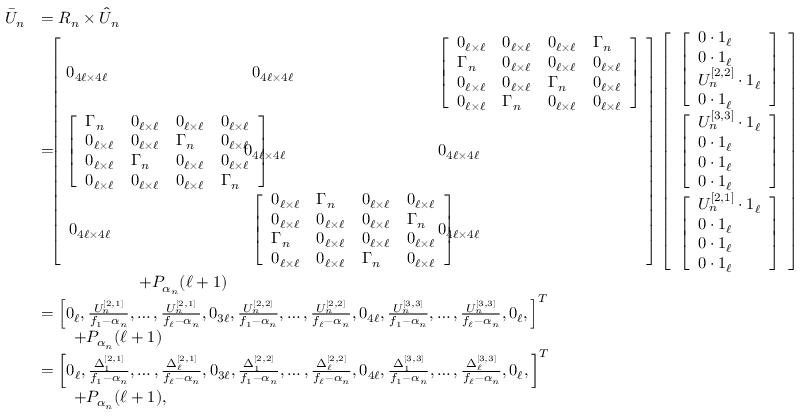<formula> <loc_0><loc_0><loc_500><loc_500>\begin{array} { r l } { \bar { U } _ { n } } & { = R _ { n } \times \hat { U } _ { n } } \\ & { = \, \left [ \begin{array} { l l l } { \, 0 _ { 4 \ell \times 4 \ell } \, } & { \, 0 _ { 4 \ell \times 4 \ell } \, } & { \, \left [ \begin{array} { l l l l } { 0 _ { \ell \times \ell } } & { 0 _ { \ell \times \ell } } & { 0 _ { \ell \times \ell } } & { \Gamma _ { n } } \\ { \Gamma _ { n } } & { 0 _ { \ell \times \ell } } & { 0 _ { \ell \times \ell } } & { 0 _ { \ell \times \ell } } \\ { 0 _ { \ell \times \ell } } & { 0 _ { \ell \times \ell } } & { \Gamma _ { n } } & { 0 _ { \ell \times \ell } } \\ { 0 _ { \ell \times \ell } } & { \Gamma _ { n } } & { 0 _ { \ell \times \ell } } & { 0 _ { \ell \times \ell } } \end{array} \right ] \, } \\ { \, \left [ \begin{array} { l l l l } { \Gamma _ { n } } & { 0 _ { \ell \times \ell } } & { 0 _ { \ell \times \ell } } & { 0 _ { \ell \times \ell } } \\ { 0 _ { \ell \times \ell } } & { 0 _ { \ell \times \ell } } & { \Gamma _ { n } } & { 0 _ { \ell \times \ell } } \\ { 0 _ { \ell \times \ell } } & { \Gamma _ { n } } & { 0 _ { \ell \times \ell } } & { 0 _ { \ell \times \ell } } \\ { 0 _ { \ell \times \ell } } & { 0 _ { \ell \times \ell } } & { 0 _ { \ell \times \ell } } & { \Gamma _ { n } } \end{array} \right ] \, } & { \, 0 _ { 4 \ell \times 4 \ell } \, } & { \, 0 _ { 4 \ell \times 4 \ell } \, } \\ { 0 _ { 4 \ell \times 4 \ell } \, } & { \, \left [ \begin{array} { l l l l } { 0 _ { \ell \times \ell } } & { \Gamma _ { n } } & { 0 _ { \ell \times \ell } } & { 0 _ { \ell \times \ell } } \\ { 0 _ { \ell \times \ell } } & { 0 _ { \ell \times \ell } } & { 0 _ { \ell \times \ell } } & { \Gamma _ { n } } \\ { \Gamma _ { n } } & { 0 _ { \ell \times \ell } } & { 0 _ { \ell \times \ell } } & { 0 _ { \ell \times \ell } } \\ { 0 _ { \ell \times \ell } } & { 0 _ { \ell \times \ell } } & { \Gamma _ { n } } & { 0 _ { \ell \times \ell } } \end{array} \right ] \, } & { \, 0 _ { 4 \ell \times 4 \ell } \, } \end{array} \right ] \left [ \begin{array} { l } { \left [ \begin{array} { l } { 0 \cdot 1 _ { \ell } } \\ { 0 \cdot 1 _ { \ell } } \\ { U _ { n } ^ { [ 2 , 2 ] } \cdot 1 _ { \ell } } \\ { 0 \cdot 1 _ { \ell } } \end{array} \right ] } \\ { \left [ \begin{array} { l } { U _ { n } ^ { [ 3 , 3 ] } \cdot 1 _ { \ell } } \\ { 0 \cdot 1 _ { \ell } } \\ { 0 \cdot 1 _ { \ell } } \\ { 0 \cdot 1 _ { \ell } } \end{array} \right ] } \\ { \left [ \begin{array} { l } { U _ { n } ^ { [ 2 , 1 ] } \cdot 1 _ { \ell } } \\ { 0 \cdot 1 _ { \ell } } \\ { 0 \cdot 1 _ { \ell } } \\ { 0 \cdot 1 _ { \ell } } \end{array} \right ] } \end{array} \right ] } \\ & { \quad + P _ { \alpha _ { n } } ( \ell + 1 ) } \\ & { = \left [ 0 _ { \ell } , \frac { U _ { n } ^ { [ 2 , 1 ] } } { f _ { 1 } - \alpha _ { n } } , \dots , \frac { U _ { n } ^ { [ 2 , 1 ] } } { f _ { \ell } - \alpha _ { n } } , 0 _ { 3 \ell } , \frac { U _ { n } ^ { [ 2 , 2 ] } } { f _ { 1 } - \alpha _ { n } } , \dots , \frac { U _ { n } ^ { [ 2 , 2 ] } } { f _ { \ell } - \alpha _ { n } } , 0 _ { 4 \ell } , \frac { U _ { n } ^ { [ 3 , 3 ] } } { f _ { 1 } - \alpha _ { n } } , \dots , \frac { U _ { n } ^ { [ 3 , 3 ] } } { f _ { \ell } - \alpha _ { n } } , 0 _ { \ell } , \right ] ^ { T } } \\ & { \quad + P _ { \alpha _ { n } } ( \ell + 1 ) } \\ & { = \left [ 0 _ { \ell } , \frac { \Delta _ { 1 } ^ { [ 2 , 1 ] } } { f _ { 1 } - \alpha _ { n } } , \dots , \frac { \Delta _ { \ell } ^ { [ 2 , 1 ] } } { f _ { \ell } - \alpha _ { n } } , 0 _ { 3 \ell } , \frac { \Delta _ { 1 } ^ { [ 2 , 2 ] } } { f _ { 1 } - \alpha _ { n } } , \dots , \frac { \Delta _ { \ell } ^ { [ 2 , 2 ] } } { f _ { \ell } - \alpha _ { n } } , 0 _ { 4 \ell } , \frac { \Delta _ { 1 } ^ { [ 3 , 3 ] } } { f _ { 1 } - \alpha _ { n } } , \dots , \frac { \Delta _ { \ell } ^ { [ 3 , 3 ] } } { f _ { \ell } - \alpha _ { n } } , 0 _ { \ell } , \right ] ^ { T } } \\ & { \quad + P _ { \alpha _ { n } } ( \ell + 1 ) , } \end{array}</formula> 